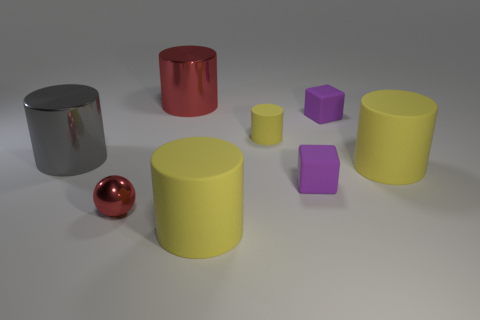Subtract all yellow cylinders. How many were subtracted if there are1yellow cylinders left? 2 Subtract all green blocks. How many yellow cylinders are left? 3 Subtract all red cylinders. How many cylinders are left? 4 Subtract all big red cylinders. How many cylinders are left? 4 Subtract all cyan cylinders. Subtract all purple balls. How many cylinders are left? 5 Add 1 red shiny cylinders. How many objects exist? 9 Subtract all spheres. How many objects are left? 7 Subtract 0 cyan spheres. How many objects are left? 8 Subtract all yellow matte blocks. Subtract all gray cylinders. How many objects are left? 7 Add 3 big yellow things. How many big yellow things are left? 5 